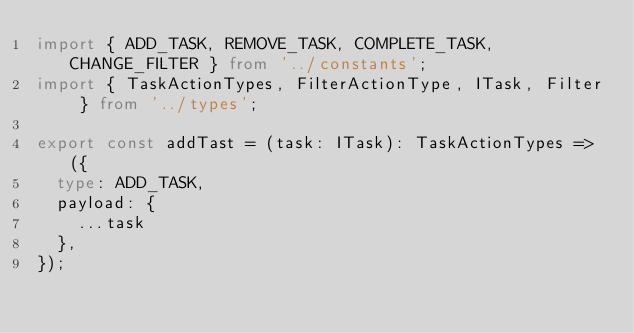<code> <loc_0><loc_0><loc_500><loc_500><_TypeScript_>import { ADD_TASK, REMOVE_TASK, COMPLETE_TASK, CHANGE_FILTER } from '../constants';
import { TaskActionTypes, FilterActionType, ITask, Filter } from '../types';

export const addTast = (task: ITask): TaskActionTypes => ({
  type: ADD_TASK,
  payload: {
    ...task
  },
});
</code> 